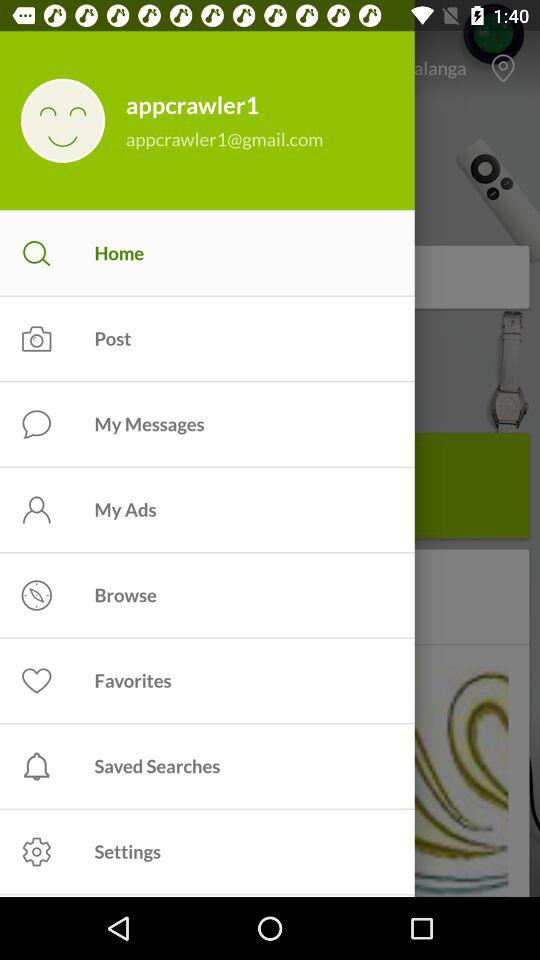What's the Google mail address? The Google mail address is appcrawler1@gmail.com. 